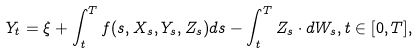<formula> <loc_0><loc_0><loc_500><loc_500>Y _ { t } = \xi + \int _ { t } ^ { T } f ( s , X _ { s } , Y _ { s } , Z _ { s } ) d s - \int _ { t } ^ { T } Z _ { s } \cdot d W _ { s } , t \in [ 0 , T ] ,</formula> 